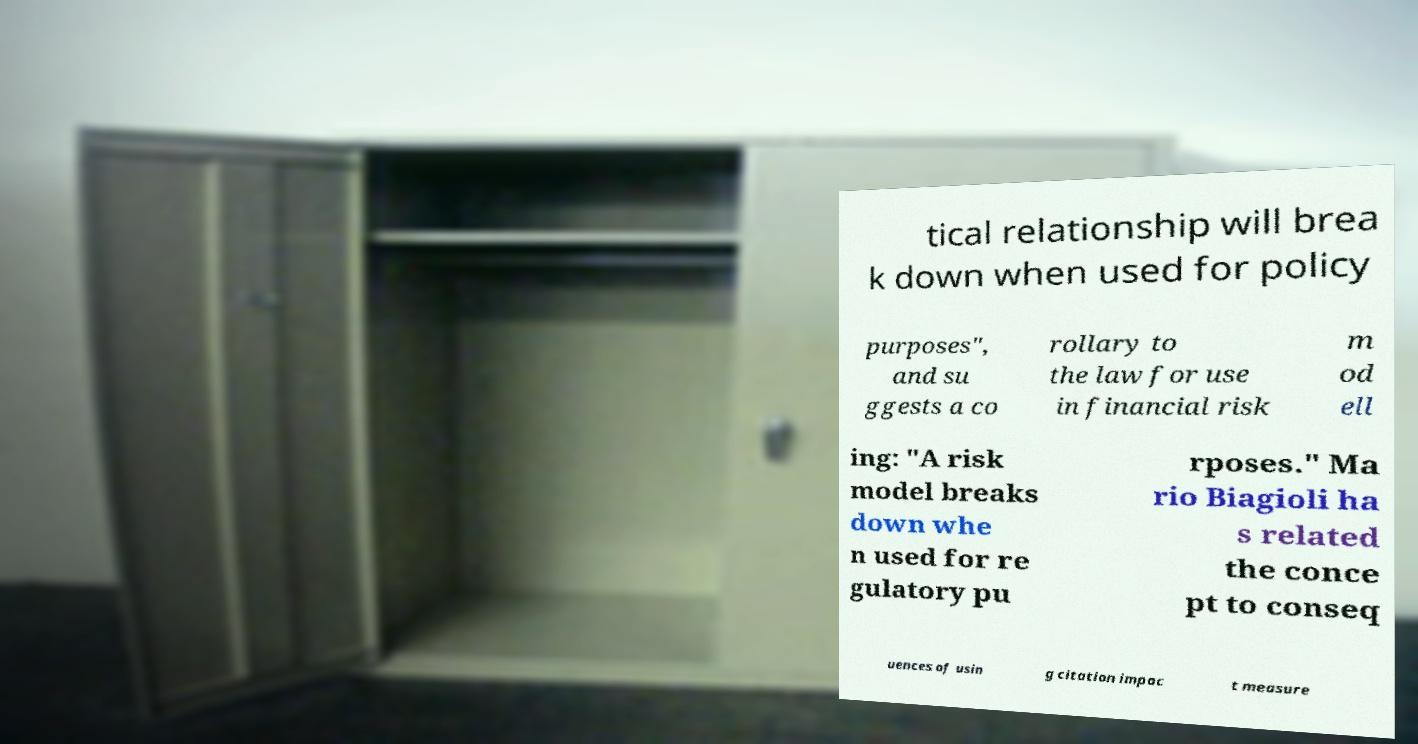What messages or text are displayed in this image? I need them in a readable, typed format. tical relationship will brea k down when used for policy purposes", and su ggests a co rollary to the law for use in financial risk m od ell ing: "A risk model breaks down whe n used for re gulatory pu rposes." Ma rio Biagioli ha s related the conce pt to conseq uences of usin g citation impac t measure 